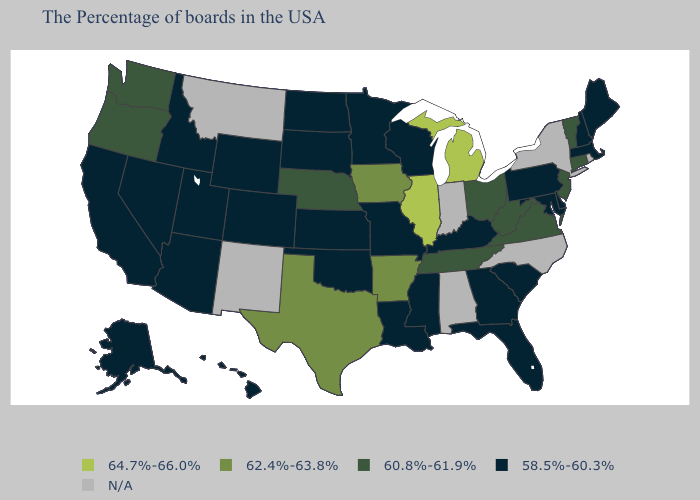What is the value of Illinois?
Short answer required. 64.7%-66.0%. What is the highest value in states that border Alabama?
Answer briefly. 60.8%-61.9%. What is the value of Alaska?
Keep it brief. 58.5%-60.3%. Does Vermont have the lowest value in the USA?
Concise answer only. No. Name the states that have a value in the range 58.5%-60.3%?
Keep it brief. Maine, Massachusetts, New Hampshire, Delaware, Maryland, Pennsylvania, South Carolina, Florida, Georgia, Kentucky, Wisconsin, Mississippi, Louisiana, Missouri, Minnesota, Kansas, Oklahoma, South Dakota, North Dakota, Wyoming, Colorado, Utah, Arizona, Idaho, Nevada, California, Alaska, Hawaii. Is the legend a continuous bar?
Answer briefly. No. Name the states that have a value in the range N/A?
Answer briefly. Rhode Island, New York, North Carolina, Indiana, Alabama, New Mexico, Montana. How many symbols are there in the legend?
Be succinct. 5. Does California have the lowest value in the USA?
Give a very brief answer. Yes. Does Arizona have the lowest value in the West?
Give a very brief answer. Yes. What is the value of Maryland?
Answer briefly. 58.5%-60.3%. What is the lowest value in the MidWest?
Be succinct. 58.5%-60.3%. Which states have the lowest value in the Northeast?
Short answer required. Maine, Massachusetts, New Hampshire, Pennsylvania. What is the value of Montana?
Short answer required. N/A. 